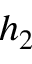Convert formula to latex. <formula><loc_0><loc_0><loc_500><loc_500>h _ { 2 }</formula> 